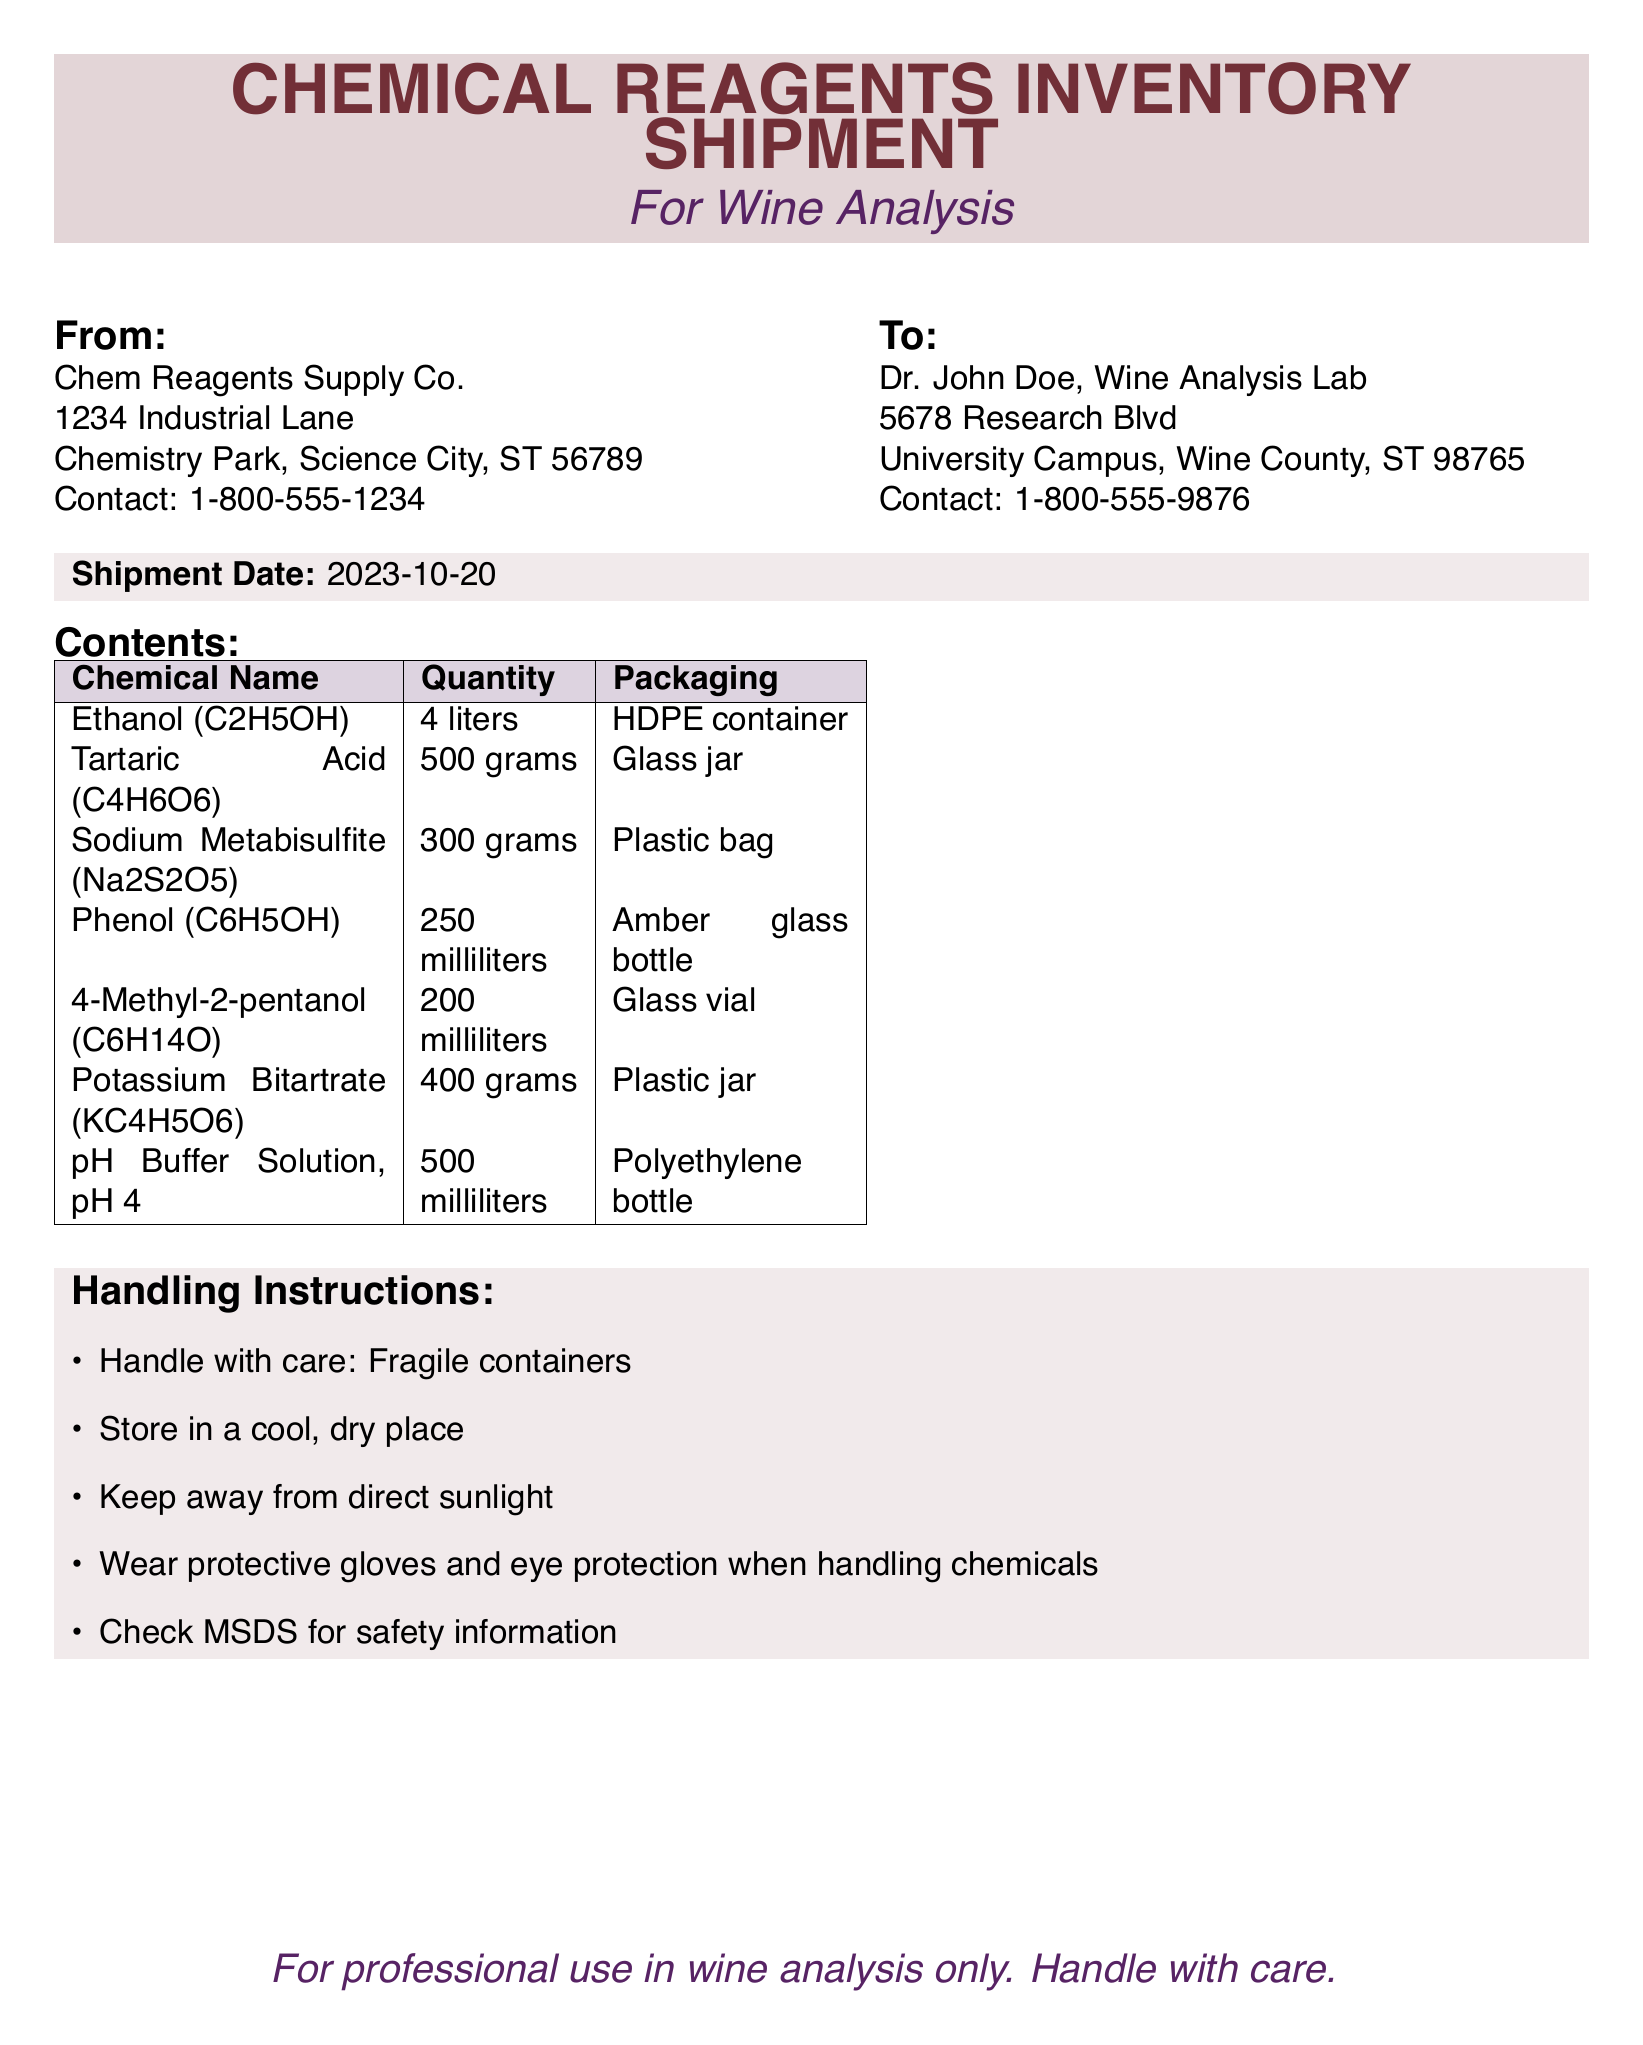What is the shipment date? The shipment date is clearly stated in the document under "Shipment Date".
Answer: 2023-10-20 Who is the sender of the shipment? The sender's information is listed under "From".
Answer: Chem Reagents Supply Co What is the quantity of Tartaric Acid? The quantity of Tartaric Acid can be found in the "Contents" section.
Answer: 500 grams What is the packaging type for Ethanol? The packaging type for Ethanol is mentioned in the "Contents" table.
Answer: HDPE container How many liters of Ethanol are included in the shipment? The quantity of Ethanol is specified in the "Contents" section.
Answer: 4 liters What safety equipment is recommended for handling chemicals? The handling instructions mention wearing protective equipment.
Answer: Protective gloves and eye protection How many different chemicals are listed in the shipment? The count of chemicals can be derived from the "Contents" table.
Answer: 7 What should you check for safety information before handling chemicals? The handling instructions suggest checking specific documentation for safety.
Answer: MSDS What is the destination of the shipment? The recipient's information is provided under "To".
Answer: Dr. John Doe, Wine Analysis Lab 